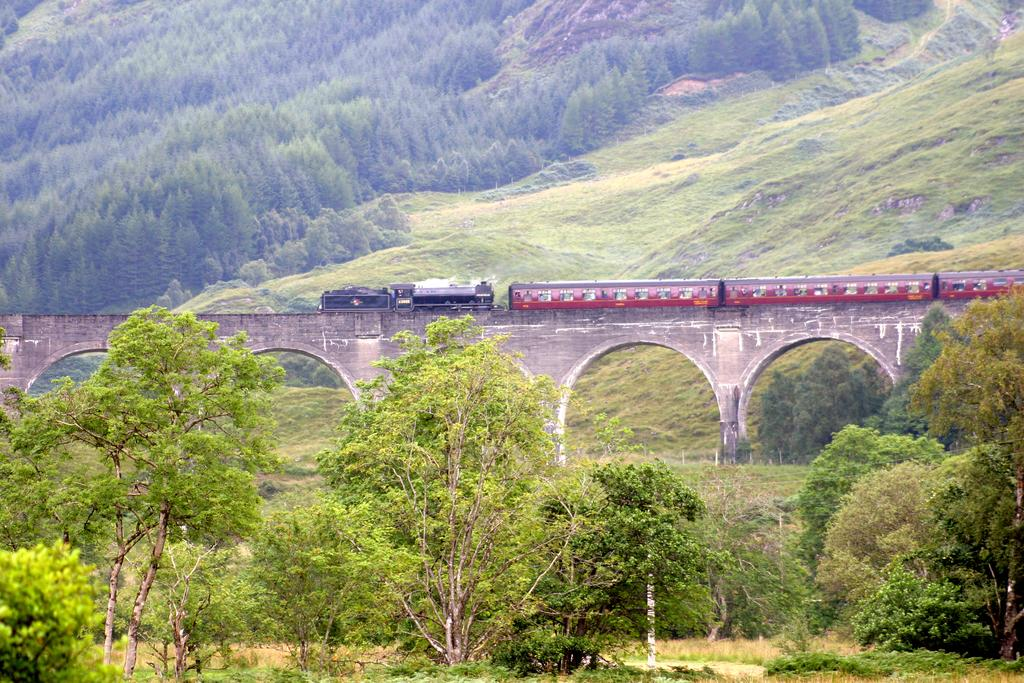What structure can be seen in the image? There is a bridge in the image. What is on the bridge? There is a train on the bridge. What type of vegetation is visible in the image? There are trees visible in the image. What type of book is the judge holding while standing on the bridge? There is no judge or book present in the image; it features a bridge with a train on it and trees in the background. 